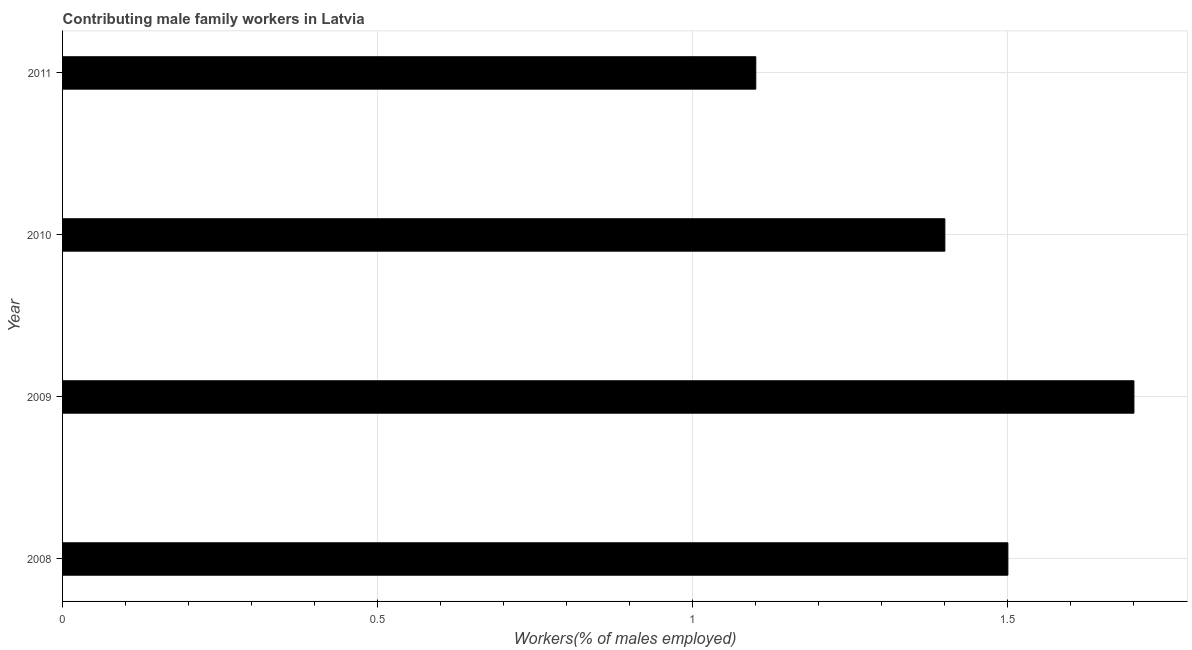Does the graph contain any zero values?
Offer a very short reply. No. Does the graph contain grids?
Ensure brevity in your answer.  Yes. What is the title of the graph?
Provide a succinct answer. Contributing male family workers in Latvia. What is the label or title of the X-axis?
Provide a succinct answer. Workers(% of males employed). What is the label or title of the Y-axis?
Your answer should be compact. Year. What is the contributing male family workers in 2010?
Give a very brief answer. 1.4. Across all years, what is the maximum contributing male family workers?
Your answer should be very brief. 1.7. Across all years, what is the minimum contributing male family workers?
Ensure brevity in your answer.  1.1. What is the sum of the contributing male family workers?
Give a very brief answer. 5.7. What is the average contributing male family workers per year?
Your answer should be very brief. 1.43. What is the median contributing male family workers?
Your answer should be compact. 1.45. Do a majority of the years between 2009 and 2010 (inclusive) have contributing male family workers greater than 1.5 %?
Offer a terse response. No. What is the ratio of the contributing male family workers in 2009 to that in 2011?
Provide a succinct answer. 1.54. Is the difference between the contributing male family workers in 2009 and 2011 greater than the difference between any two years?
Make the answer very short. Yes. How many bars are there?
Provide a short and direct response. 4. What is the Workers(% of males employed) of 2008?
Your answer should be very brief. 1.5. What is the Workers(% of males employed) in 2009?
Your response must be concise. 1.7. What is the Workers(% of males employed) in 2010?
Offer a terse response. 1.4. What is the Workers(% of males employed) in 2011?
Ensure brevity in your answer.  1.1. What is the difference between the Workers(% of males employed) in 2008 and 2010?
Your answer should be very brief. 0.1. What is the difference between the Workers(% of males employed) in 2008 and 2011?
Keep it short and to the point. 0.4. What is the ratio of the Workers(% of males employed) in 2008 to that in 2009?
Your answer should be very brief. 0.88. What is the ratio of the Workers(% of males employed) in 2008 to that in 2010?
Offer a very short reply. 1.07. What is the ratio of the Workers(% of males employed) in 2008 to that in 2011?
Provide a succinct answer. 1.36. What is the ratio of the Workers(% of males employed) in 2009 to that in 2010?
Provide a short and direct response. 1.21. What is the ratio of the Workers(% of males employed) in 2009 to that in 2011?
Give a very brief answer. 1.54. What is the ratio of the Workers(% of males employed) in 2010 to that in 2011?
Provide a succinct answer. 1.27. 